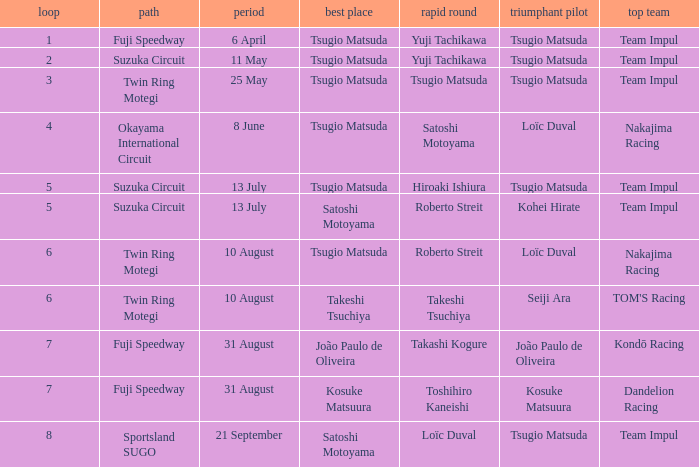On what date does Yuji Tachikawa have the fastest lap in round 1? 6 April. 